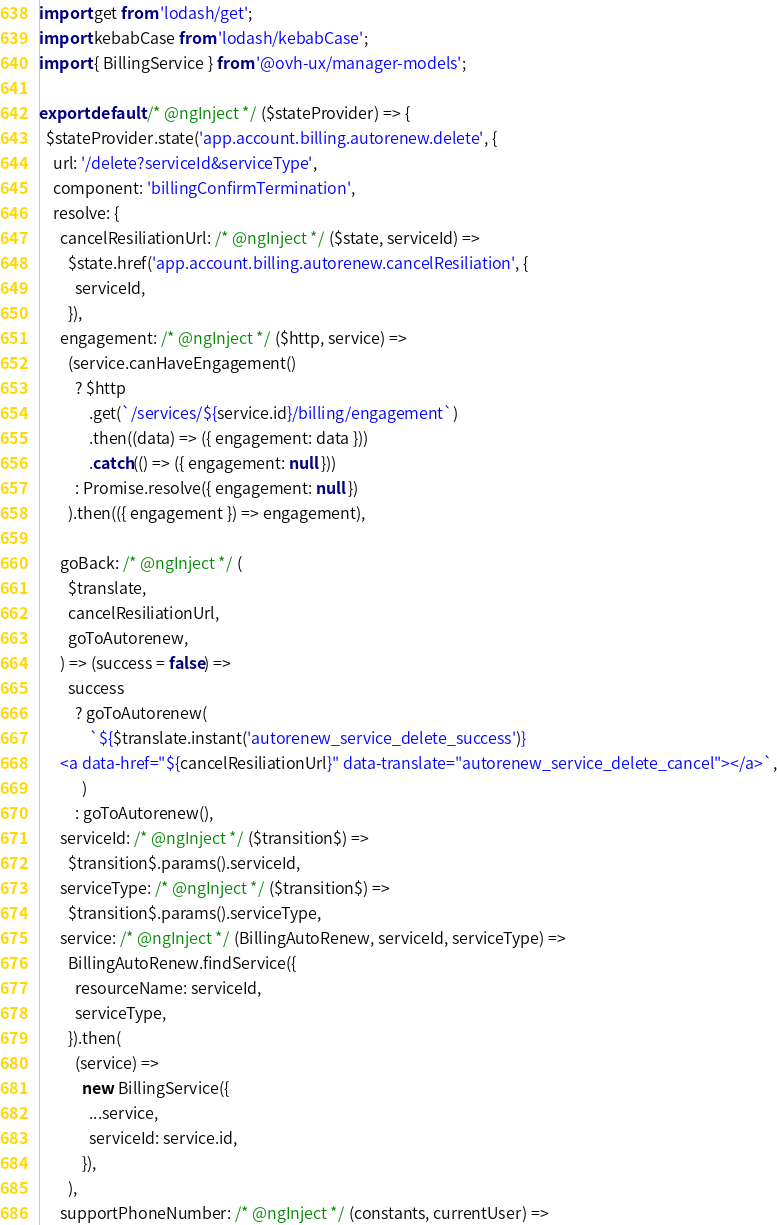Convert code to text. <code><loc_0><loc_0><loc_500><loc_500><_JavaScript_>import get from 'lodash/get';
import kebabCase from 'lodash/kebabCase';
import { BillingService } from '@ovh-ux/manager-models';

export default /* @ngInject */ ($stateProvider) => {
  $stateProvider.state('app.account.billing.autorenew.delete', {
    url: '/delete?serviceId&serviceType',
    component: 'billingConfirmTermination',
    resolve: {
      cancelResiliationUrl: /* @ngInject */ ($state, serviceId) =>
        $state.href('app.account.billing.autorenew.cancelResiliation', {
          serviceId,
        }),
      engagement: /* @ngInject */ ($http, service) =>
        (service.canHaveEngagement()
          ? $http
              .get(`/services/${service.id}/billing/engagement`)
              .then((data) => ({ engagement: data }))
              .catch(() => ({ engagement: null }))
          : Promise.resolve({ engagement: null })
        ).then(({ engagement }) => engagement),

      goBack: /* @ngInject */ (
        $translate,
        cancelResiliationUrl,
        goToAutorenew,
      ) => (success = false) =>
        success
          ? goToAutorenew(
              `${$translate.instant('autorenew_service_delete_success')}
      <a data-href="${cancelResiliationUrl}" data-translate="autorenew_service_delete_cancel"></a>`,
            )
          : goToAutorenew(),
      serviceId: /* @ngInject */ ($transition$) =>
        $transition$.params().serviceId,
      serviceType: /* @ngInject */ ($transition$) =>
        $transition$.params().serviceType,
      service: /* @ngInject */ (BillingAutoRenew, serviceId, serviceType) =>
        BillingAutoRenew.findService({
          resourceName: serviceId,
          serviceType,
        }).then(
          (service) =>
            new BillingService({
              ...service,
              serviceId: service.id,
            }),
        ),
      supportPhoneNumber: /* @ngInject */ (constants, currentUser) =></code> 